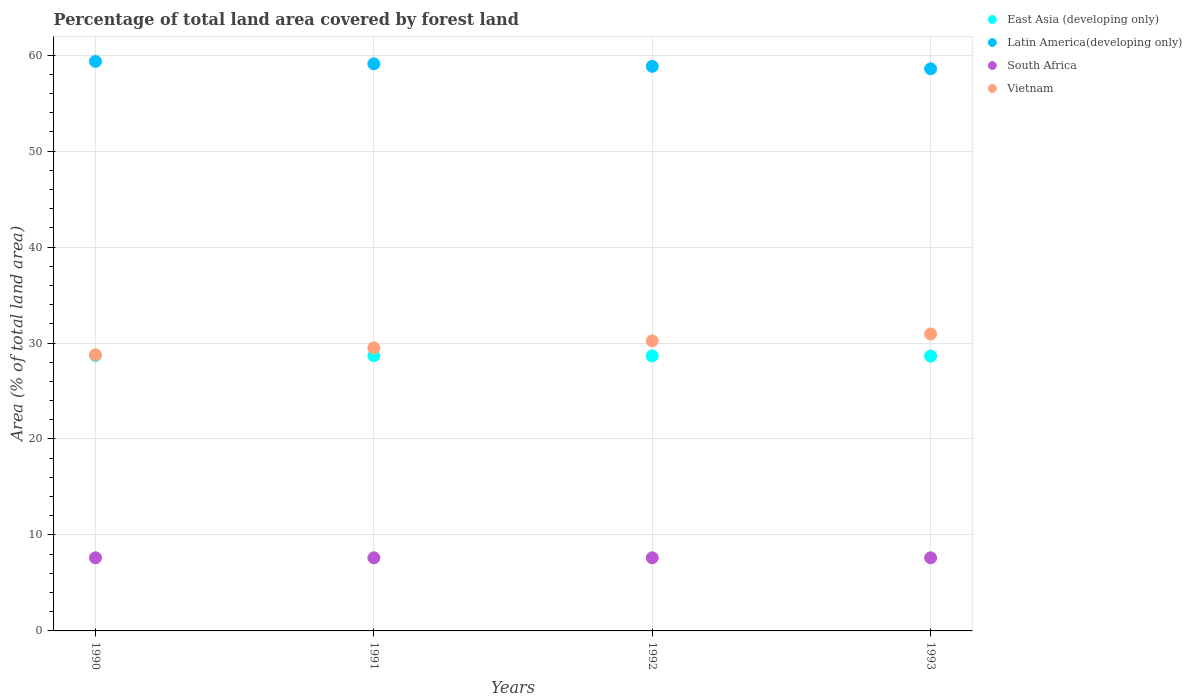Is the number of dotlines equal to the number of legend labels?
Your answer should be very brief. Yes. What is the percentage of forest land in Vietnam in 1991?
Make the answer very short. 29.49. Across all years, what is the maximum percentage of forest land in South Africa?
Ensure brevity in your answer.  7.62. Across all years, what is the minimum percentage of forest land in Latin America(developing only)?
Your response must be concise. 58.57. What is the total percentage of forest land in South Africa in the graph?
Make the answer very short. 30.47. What is the difference between the percentage of forest land in East Asia (developing only) in 1990 and that in 1992?
Provide a short and direct response. 0.04. What is the difference between the percentage of forest land in Latin America(developing only) in 1993 and the percentage of forest land in East Asia (developing only) in 1991?
Offer a terse response. 29.89. What is the average percentage of forest land in East Asia (developing only) per year?
Provide a succinct answer. 28.66. In the year 1990, what is the difference between the percentage of forest land in Vietnam and percentage of forest land in East Asia (developing only)?
Give a very brief answer. 0.07. In how many years, is the percentage of forest land in Latin America(developing only) greater than 38 %?
Offer a terse response. 4. What is the ratio of the percentage of forest land in East Asia (developing only) in 1991 to that in 1992?
Your response must be concise. 1. What is the difference between the highest and the second highest percentage of forest land in East Asia (developing only)?
Give a very brief answer. 0.02. What is the difference between the highest and the lowest percentage of forest land in South Africa?
Your answer should be very brief. 0. Is it the case that in every year, the sum of the percentage of forest land in East Asia (developing only) and percentage of forest land in South Africa  is greater than the sum of percentage of forest land in Latin America(developing only) and percentage of forest land in Vietnam?
Your answer should be compact. No. Is it the case that in every year, the sum of the percentage of forest land in Vietnam and percentage of forest land in East Asia (developing only)  is greater than the percentage of forest land in Latin America(developing only)?
Offer a terse response. No. Does the percentage of forest land in South Africa monotonically increase over the years?
Ensure brevity in your answer.  No. Is the percentage of forest land in East Asia (developing only) strictly greater than the percentage of forest land in Vietnam over the years?
Your answer should be very brief. No. How many years are there in the graph?
Provide a short and direct response. 4. What is the difference between two consecutive major ticks on the Y-axis?
Provide a succinct answer. 10. Are the values on the major ticks of Y-axis written in scientific E-notation?
Offer a terse response. No. Does the graph contain any zero values?
Offer a very short reply. No. Does the graph contain grids?
Provide a succinct answer. Yes. What is the title of the graph?
Provide a succinct answer. Percentage of total land area covered by forest land. What is the label or title of the X-axis?
Offer a very short reply. Years. What is the label or title of the Y-axis?
Your answer should be compact. Area (% of total land area). What is the Area (% of total land area) in East Asia (developing only) in 1990?
Make the answer very short. 28.69. What is the Area (% of total land area) in Latin America(developing only) in 1990?
Keep it short and to the point. 59.34. What is the Area (% of total land area) of South Africa in 1990?
Your answer should be very brief. 7.62. What is the Area (% of total land area) in Vietnam in 1990?
Offer a very short reply. 28.77. What is the Area (% of total land area) of East Asia (developing only) in 1991?
Provide a succinct answer. 28.68. What is the Area (% of total land area) of Latin America(developing only) in 1991?
Keep it short and to the point. 59.09. What is the Area (% of total land area) of South Africa in 1991?
Your answer should be compact. 7.62. What is the Area (% of total land area) of Vietnam in 1991?
Offer a terse response. 29.49. What is the Area (% of total land area) in East Asia (developing only) in 1992?
Make the answer very short. 28.65. What is the Area (% of total land area) in Latin America(developing only) in 1992?
Your answer should be very brief. 58.83. What is the Area (% of total land area) of South Africa in 1992?
Give a very brief answer. 7.62. What is the Area (% of total land area) of Vietnam in 1992?
Offer a very short reply. 30.22. What is the Area (% of total land area) of East Asia (developing only) in 1993?
Your response must be concise. 28.63. What is the Area (% of total land area) in Latin America(developing only) in 1993?
Make the answer very short. 58.57. What is the Area (% of total land area) of South Africa in 1993?
Offer a very short reply. 7.62. What is the Area (% of total land area) of Vietnam in 1993?
Your answer should be compact. 30.94. Across all years, what is the maximum Area (% of total land area) of East Asia (developing only)?
Ensure brevity in your answer.  28.69. Across all years, what is the maximum Area (% of total land area) of Latin America(developing only)?
Your answer should be very brief. 59.34. Across all years, what is the maximum Area (% of total land area) of South Africa?
Your answer should be very brief. 7.62. Across all years, what is the maximum Area (% of total land area) in Vietnam?
Your response must be concise. 30.94. Across all years, what is the minimum Area (% of total land area) in East Asia (developing only)?
Your response must be concise. 28.63. Across all years, what is the minimum Area (% of total land area) of Latin America(developing only)?
Your answer should be compact. 58.57. Across all years, what is the minimum Area (% of total land area) in South Africa?
Provide a short and direct response. 7.62. Across all years, what is the minimum Area (% of total land area) of Vietnam?
Offer a terse response. 28.77. What is the total Area (% of total land area) in East Asia (developing only) in the graph?
Ensure brevity in your answer.  114.66. What is the total Area (% of total land area) in Latin America(developing only) in the graph?
Provide a succinct answer. 235.83. What is the total Area (% of total land area) in South Africa in the graph?
Your answer should be compact. 30.47. What is the total Area (% of total land area) of Vietnam in the graph?
Make the answer very short. 119.42. What is the difference between the Area (% of total land area) in East Asia (developing only) in 1990 and that in 1991?
Ensure brevity in your answer.  0.02. What is the difference between the Area (% of total land area) in Latin America(developing only) in 1990 and that in 1991?
Offer a very short reply. 0.26. What is the difference between the Area (% of total land area) in Vietnam in 1990 and that in 1991?
Offer a very short reply. -0.73. What is the difference between the Area (% of total land area) in East Asia (developing only) in 1990 and that in 1992?
Your answer should be compact. 0.04. What is the difference between the Area (% of total land area) of Latin America(developing only) in 1990 and that in 1992?
Ensure brevity in your answer.  0.52. What is the difference between the Area (% of total land area) of South Africa in 1990 and that in 1992?
Ensure brevity in your answer.  0. What is the difference between the Area (% of total land area) of Vietnam in 1990 and that in 1992?
Ensure brevity in your answer.  -1.45. What is the difference between the Area (% of total land area) in East Asia (developing only) in 1990 and that in 1993?
Offer a very short reply. 0.06. What is the difference between the Area (% of total land area) in Latin America(developing only) in 1990 and that in 1993?
Make the answer very short. 0.77. What is the difference between the Area (% of total land area) of Vietnam in 1990 and that in 1993?
Your response must be concise. -2.18. What is the difference between the Area (% of total land area) of East Asia (developing only) in 1991 and that in 1992?
Offer a terse response. 0.02. What is the difference between the Area (% of total land area) in Latin America(developing only) in 1991 and that in 1992?
Provide a short and direct response. 0.26. What is the difference between the Area (% of total land area) of South Africa in 1991 and that in 1992?
Your answer should be very brief. 0. What is the difference between the Area (% of total land area) in Vietnam in 1991 and that in 1992?
Provide a succinct answer. -0.73. What is the difference between the Area (% of total land area) of East Asia (developing only) in 1991 and that in 1993?
Provide a succinct answer. 0.04. What is the difference between the Area (% of total land area) in Latin America(developing only) in 1991 and that in 1993?
Give a very brief answer. 0.52. What is the difference between the Area (% of total land area) of South Africa in 1991 and that in 1993?
Ensure brevity in your answer.  0. What is the difference between the Area (% of total land area) in Vietnam in 1991 and that in 1993?
Give a very brief answer. -1.45. What is the difference between the Area (% of total land area) in East Asia (developing only) in 1992 and that in 1993?
Your answer should be compact. 0.02. What is the difference between the Area (% of total land area) in Latin America(developing only) in 1992 and that in 1993?
Keep it short and to the point. 0.26. What is the difference between the Area (% of total land area) in South Africa in 1992 and that in 1993?
Offer a very short reply. 0. What is the difference between the Area (% of total land area) in Vietnam in 1992 and that in 1993?
Your answer should be compact. -0.73. What is the difference between the Area (% of total land area) of East Asia (developing only) in 1990 and the Area (% of total land area) of Latin America(developing only) in 1991?
Make the answer very short. -30.39. What is the difference between the Area (% of total land area) of East Asia (developing only) in 1990 and the Area (% of total land area) of South Africa in 1991?
Keep it short and to the point. 21.07. What is the difference between the Area (% of total land area) in East Asia (developing only) in 1990 and the Area (% of total land area) in Vietnam in 1991?
Provide a short and direct response. -0.8. What is the difference between the Area (% of total land area) in Latin America(developing only) in 1990 and the Area (% of total land area) in South Africa in 1991?
Give a very brief answer. 51.73. What is the difference between the Area (% of total land area) of Latin America(developing only) in 1990 and the Area (% of total land area) of Vietnam in 1991?
Provide a succinct answer. 29.85. What is the difference between the Area (% of total land area) in South Africa in 1990 and the Area (% of total land area) in Vietnam in 1991?
Your answer should be compact. -21.87. What is the difference between the Area (% of total land area) in East Asia (developing only) in 1990 and the Area (% of total land area) in Latin America(developing only) in 1992?
Provide a succinct answer. -30.14. What is the difference between the Area (% of total land area) of East Asia (developing only) in 1990 and the Area (% of total land area) of South Africa in 1992?
Offer a very short reply. 21.07. What is the difference between the Area (% of total land area) in East Asia (developing only) in 1990 and the Area (% of total land area) in Vietnam in 1992?
Give a very brief answer. -1.53. What is the difference between the Area (% of total land area) in Latin America(developing only) in 1990 and the Area (% of total land area) in South Africa in 1992?
Offer a very short reply. 51.73. What is the difference between the Area (% of total land area) in Latin America(developing only) in 1990 and the Area (% of total land area) in Vietnam in 1992?
Your response must be concise. 29.13. What is the difference between the Area (% of total land area) of South Africa in 1990 and the Area (% of total land area) of Vietnam in 1992?
Give a very brief answer. -22.6. What is the difference between the Area (% of total land area) in East Asia (developing only) in 1990 and the Area (% of total land area) in Latin America(developing only) in 1993?
Ensure brevity in your answer.  -29.88. What is the difference between the Area (% of total land area) of East Asia (developing only) in 1990 and the Area (% of total land area) of South Africa in 1993?
Ensure brevity in your answer.  21.07. What is the difference between the Area (% of total land area) in East Asia (developing only) in 1990 and the Area (% of total land area) in Vietnam in 1993?
Provide a succinct answer. -2.25. What is the difference between the Area (% of total land area) in Latin America(developing only) in 1990 and the Area (% of total land area) in South Africa in 1993?
Ensure brevity in your answer.  51.73. What is the difference between the Area (% of total land area) of Latin America(developing only) in 1990 and the Area (% of total land area) of Vietnam in 1993?
Provide a short and direct response. 28.4. What is the difference between the Area (% of total land area) of South Africa in 1990 and the Area (% of total land area) of Vietnam in 1993?
Offer a very short reply. -23.33. What is the difference between the Area (% of total land area) of East Asia (developing only) in 1991 and the Area (% of total land area) of Latin America(developing only) in 1992?
Keep it short and to the point. -30.15. What is the difference between the Area (% of total land area) of East Asia (developing only) in 1991 and the Area (% of total land area) of South Africa in 1992?
Offer a very short reply. 21.06. What is the difference between the Area (% of total land area) in East Asia (developing only) in 1991 and the Area (% of total land area) in Vietnam in 1992?
Provide a succinct answer. -1.54. What is the difference between the Area (% of total land area) in Latin America(developing only) in 1991 and the Area (% of total land area) in South Africa in 1992?
Your response must be concise. 51.47. What is the difference between the Area (% of total land area) of Latin America(developing only) in 1991 and the Area (% of total land area) of Vietnam in 1992?
Keep it short and to the point. 28.87. What is the difference between the Area (% of total land area) of South Africa in 1991 and the Area (% of total land area) of Vietnam in 1992?
Provide a short and direct response. -22.6. What is the difference between the Area (% of total land area) of East Asia (developing only) in 1991 and the Area (% of total land area) of Latin America(developing only) in 1993?
Your answer should be very brief. -29.89. What is the difference between the Area (% of total land area) in East Asia (developing only) in 1991 and the Area (% of total land area) in South Africa in 1993?
Offer a very short reply. 21.06. What is the difference between the Area (% of total land area) in East Asia (developing only) in 1991 and the Area (% of total land area) in Vietnam in 1993?
Keep it short and to the point. -2.27. What is the difference between the Area (% of total land area) of Latin America(developing only) in 1991 and the Area (% of total land area) of South Africa in 1993?
Make the answer very short. 51.47. What is the difference between the Area (% of total land area) of Latin America(developing only) in 1991 and the Area (% of total land area) of Vietnam in 1993?
Provide a succinct answer. 28.14. What is the difference between the Area (% of total land area) in South Africa in 1991 and the Area (% of total land area) in Vietnam in 1993?
Give a very brief answer. -23.33. What is the difference between the Area (% of total land area) in East Asia (developing only) in 1992 and the Area (% of total land area) in Latin America(developing only) in 1993?
Offer a very short reply. -29.92. What is the difference between the Area (% of total land area) in East Asia (developing only) in 1992 and the Area (% of total land area) in South Africa in 1993?
Keep it short and to the point. 21.04. What is the difference between the Area (% of total land area) in East Asia (developing only) in 1992 and the Area (% of total land area) in Vietnam in 1993?
Give a very brief answer. -2.29. What is the difference between the Area (% of total land area) of Latin America(developing only) in 1992 and the Area (% of total land area) of South Africa in 1993?
Give a very brief answer. 51.21. What is the difference between the Area (% of total land area) of Latin America(developing only) in 1992 and the Area (% of total land area) of Vietnam in 1993?
Your response must be concise. 27.88. What is the difference between the Area (% of total land area) of South Africa in 1992 and the Area (% of total land area) of Vietnam in 1993?
Offer a terse response. -23.33. What is the average Area (% of total land area) of East Asia (developing only) per year?
Offer a terse response. 28.66. What is the average Area (% of total land area) in Latin America(developing only) per year?
Ensure brevity in your answer.  58.96. What is the average Area (% of total land area) of South Africa per year?
Your answer should be very brief. 7.62. What is the average Area (% of total land area) in Vietnam per year?
Your response must be concise. 29.86. In the year 1990, what is the difference between the Area (% of total land area) of East Asia (developing only) and Area (% of total land area) of Latin America(developing only)?
Ensure brevity in your answer.  -30.65. In the year 1990, what is the difference between the Area (% of total land area) of East Asia (developing only) and Area (% of total land area) of South Africa?
Offer a very short reply. 21.07. In the year 1990, what is the difference between the Area (% of total land area) in East Asia (developing only) and Area (% of total land area) in Vietnam?
Offer a terse response. -0.07. In the year 1990, what is the difference between the Area (% of total land area) in Latin America(developing only) and Area (% of total land area) in South Africa?
Your response must be concise. 51.73. In the year 1990, what is the difference between the Area (% of total land area) in Latin America(developing only) and Area (% of total land area) in Vietnam?
Provide a short and direct response. 30.58. In the year 1990, what is the difference between the Area (% of total land area) in South Africa and Area (% of total land area) in Vietnam?
Ensure brevity in your answer.  -21.15. In the year 1991, what is the difference between the Area (% of total land area) in East Asia (developing only) and Area (% of total land area) in Latin America(developing only)?
Ensure brevity in your answer.  -30.41. In the year 1991, what is the difference between the Area (% of total land area) in East Asia (developing only) and Area (% of total land area) in South Africa?
Provide a short and direct response. 21.06. In the year 1991, what is the difference between the Area (% of total land area) of East Asia (developing only) and Area (% of total land area) of Vietnam?
Ensure brevity in your answer.  -0.82. In the year 1991, what is the difference between the Area (% of total land area) of Latin America(developing only) and Area (% of total land area) of South Africa?
Provide a succinct answer. 51.47. In the year 1991, what is the difference between the Area (% of total land area) of Latin America(developing only) and Area (% of total land area) of Vietnam?
Offer a terse response. 29.59. In the year 1991, what is the difference between the Area (% of total land area) in South Africa and Area (% of total land area) in Vietnam?
Provide a succinct answer. -21.87. In the year 1992, what is the difference between the Area (% of total land area) in East Asia (developing only) and Area (% of total land area) in Latin America(developing only)?
Offer a very short reply. -30.17. In the year 1992, what is the difference between the Area (% of total land area) of East Asia (developing only) and Area (% of total land area) of South Africa?
Provide a succinct answer. 21.04. In the year 1992, what is the difference between the Area (% of total land area) of East Asia (developing only) and Area (% of total land area) of Vietnam?
Provide a succinct answer. -1.56. In the year 1992, what is the difference between the Area (% of total land area) of Latin America(developing only) and Area (% of total land area) of South Africa?
Give a very brief answer. 51.21. In the year 1992, what is the difference between the Area (% of total land area) in Latin America(developing only) and Area (% of total land area) in Vietnam?
Your answer should be compact. 28.61. In the year 1992, what is the difference between the Area (% of total land area) of South Africa and Area (% of total land area) of Vietnam?
Provide a succinct answer. -22.6. In the year 1993, what is the difference between the Area (% of total land area) in East Asia (developing only) and Area (% of total land area) in Latin America(developing only)?
Provide a short and direct response. -29.94. In the year 1993, what is the difference between the Area (% of total land area) in East Asia (developing only) and Area (% of total land area) in South Africa?
Your response must be concise. 21.02. In the year 1993, what is the difference between the Area (% of total land area) in East Asia (developing only) and Area (% of total land area) in Vietnam?
Your answer should be compact. -2.31. In the year 1993, what is the difference between the Area (% of total land area) of Latin America(developing only) and Area (% of total land area) of South Africa?
Give a very brief answer. 50.95. In the year 1993, what is the difference between the Area (% of total land area) of Latin America(developing only) and Area (% of total land area) of Vietnam?
Keep it short and to the point. 27.63. In the year 1993, what is the difference between the Area (% of total land area) of South Africa and Area (% of total land area) of Vietnam?
Offer a terse response. -23.33. What is the ratio of the Area (% of total land area) in Latin America(developing only) in 1990 to that in 1991?
Your answer should be compact. 1. What is the ratio of the Area (% of total land area) in Vietnam in 1990 to that in 1991?
Your response must be concise. 0.98. What is the ratio of the Area (% of total land area) of Latin America(developing only) in 1990 to that in 1992?
Your answer should be very brief. 1.01. What is the ratio of the Area (% of total land area) in Vietnam in 1990 to that in 1992?
Offer a very short reply. 0.95. What is the ratio of the Area (% of total land area) in Latin America(developing only) in 1990 to that in 1993?
Provide a succinct answer. 1.01. What is the ratio of the Area (% of total land area) in South Africa in 1990 to that in 1993?
Keep it short and to the point. 1. What is the ratio of the Area (% of total land area) in Vietnam in 1990 to that in 1993?
Ensure brevity in your answer.  0.93. What is the ratio of the Area (% of total land area) of Latin America(developing only) in 1991 to that in 1992?
Keep it short and to the point. 1. What is the ratio of the Area (% of total land area) in South Africa in 1991 to that in 1992?
Offer a very short reply. 1. What is the ratio of the Area (% of total land area) in Latin America(developing only) in 1991 to that in 1993?
Provide a short and direct response. 1.01. What is the ratio of the Area (% of total land area) in Vietnam in 1991 to that in 1993?
Make the answer very short. 0.95. What is the ratio of the Area (% of total land area) in South Africa in 1992 to that in 1993?
Your answer should be very brief. 1. What is the ratio of the Area (% of total land area) in Vietnam in 1992 to that in 1993?
Keep it short and to the point. 0.98. What is the difference between the highest and the second highest Area (% of total land area) of East Asia (developing only)?
Provide a short and direct response. 0.02. What is the difference between the highest and the second highest Area (% of total land area) of Latin America(developing only)?
Offer a terse response. 0.26. What is the difference between the highest and the second highest Area (% of total land area) of South Africa?
Make the answer very short. 0. What is the difference between the highest and the second highest Area (% of total land area) in Vietnam?
Offer a terse response. 0.73. What is the difference between the highest and the lowest Area (% of total land area) in East Asia (developing only)?
Provide a short and direct response. 0.06. What is the difference between the highest and the lowest Area (% of total land area) in Latin America(developing only)?
Offer a very short reply. 0.77. What is the difference between the highest and the lowest Area (% of total land area) in Vietnam?
Your answer should be compact. 2.18. 